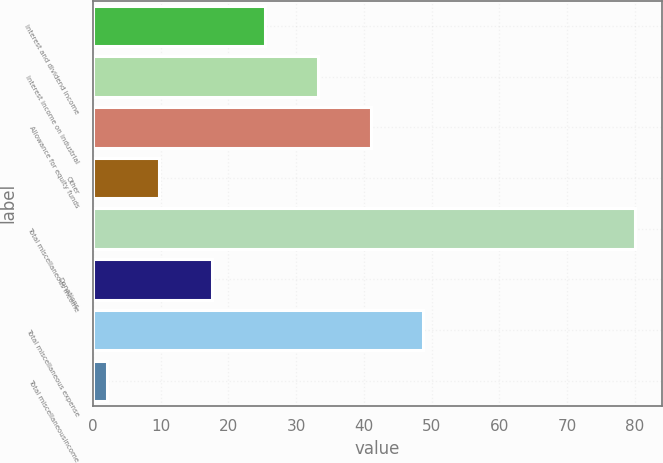<chart> <loc_0><loc_0><loc_500><loc_500><bar_chart><fcel>Interest and dividend income<fcel>Interest income on industrial<fcel>Allowance for equity funds<fcel>Other<fcel>Total miscellaneous income<fcel>Donations<fcel>Total miscellaneous expense<fcel>Total miscellaneousincome<nl><fcel>25.4<fcel>33.2<fcel>41<fcel>9.8<fcel>80<fcel>17.6<fcel>48.8<fcel>2<nl></chart> 